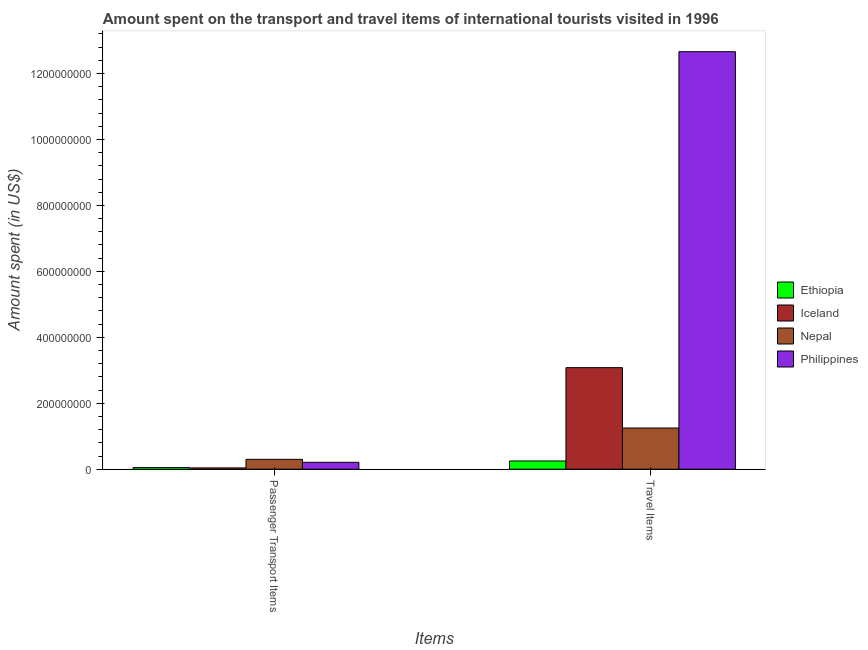How many groups of bars are there?
Ensure brevity in your answer.  2. What is the label of the 2nd group of bars from the left?
Provide a succinct answer. Travel Items. What is the amount spent in travel items in Nepal?
Provide a short and direct response. 1.25e+08. Across all countries, what is the maximum amount spent on passenger transport items?
Provide a short and direct response. 3.00e+07. Across all countries, what is the minimum amount spent on passenger transport items?
Give a very brief answer. 4.00e+06. In which country was the amount spent on passenger transport items maximum?
Offer a very short reply. Nepal. What is the total amount spent on passenger transport items in the graph?
Your answer should be compact. 6.00e+07. What is the difference between the amount spent on passenger transport items in Nepal and that in Iceland?
Provide a short and direct response. 2.60e+07. What is the difference between the amount spent on passenger transport items in Iceland and the amount spent in travel items in Ethiopia?
Give a very brief answer. -2.10e+07. What is the average amount spent in travel items per country?
Ensure brevity in your answer.  4.31e+08. What is the difference between the amount spent in travel items and amount spent on passenger transport items in Ethiopia?
Provide a succinct answer. 2.00e+07. What is the ratio of the amount spent in travel items in Philippines to that in Iceland?
Your answer should be very brief. 4.11. Is the amount spent in travel items in Nepal less than that in Iceland?
Your response must be concise. Yes. What does the 3rd bar from the left in Passenger Transport Items represents?
Your answer should be compact. Nepal. What does the 1st bar from the right in Travel Items represents?
Make the answer very short. Philippines. Are the values on the major ticks of Y-axis written in scientific E-notation?
Your answer should be very brief. No. Does the graph contain grids?
Provide a short and direct response. No. How many legend labels are there?
Make the answer very short. 4. What is the title of the graph?
Give a very brief answer. Amount spent on the transport and travel items of international tourists visited in 1996. Does "Botswana" appear as one of the legend labels in the graph?
Ensure brevity in your answer.  No. What is the label or title of the X-axis?
Your answer should be compact. Items. What is the label or title of the Y-axis?
Provide a short and direct response. Amount spent (in US$). What is the Amount spent (in US$) in Ethiopia in Passenger Transport Items?
Make the answer very short. 5.00e+06. What is the Amount spent (in US$) in Nepal in Passenger Transport Items?
Your answer should be very brief. 3.00e+07. What is the Amount spent (in US$) of Philippines in Passenger Transport Items?
Your answer should be very brief. 2.10e+07. What is the Amount spent (in US$) in Ethiopia in Travel Items?
Provide a succinct answer. 2.50e+07. What is the Amount spent (in US$) in Iceland in Travel Items?
Provide a short and direct response. 3.08e+08. What is the Amount spent (in US$) in Nepal in Travel Items?
Make the answer very short. 1.25e+08. What is the Amount spent (in US$) of Philippines in Travel Items?
Offer a very short reply. 1.27e+09. Across all Items, what is the maximum Amount spent (in US$) of Ethiopia?
Make the answer very short. 2.50e+07. Across all Items, what is the maximum Amount spent (in US$) in Iceland?
Your answer should be very brief. 3.08e+08. Across all Items, what is the maximum Amount spent (in US$) in Nepal?
Keep it short and to the point. 1.25e+08. Across all Items, what is the maximum Amount spent (in US$) of Philippines?
Give a very brief answer. 1.27e+09. Across all Items, what is the minimum Amount spent (in US$) of Ethiopia?
Offer a terse response. 5.00e+06. Across all Items, what is the minimum Amount spent (in US$) in Nepal?
Your answer should be compact. 3.00e+07. Across all Items, what is the minimum Amount spent (in US$) of Philippines?
Provide a short and direct response. 2.10e+07. What is the total Amount spent (in US$) in Ethiopia in the graph?
Provide a succinct answer. 3.00e+07. What is the total Amount spent (in US$) of Iceland in the graph?
Offer a very short reply. 3.12e+08. What is the total Amount spent (in US$) of Nepal in the graph?
Your answer should be compact. 1.55e+08. What is the total Amount spent (in US$) of Philippines in the graph?
Keep it short and to the point. 1.29e+09. What is the difference between the Amount spent (in US$) in Ethiopia in Passenger Transport Items and that in Travel Items?
Your answer should be compact. -2.00e+07. What is the difference between the Amount spent (in US$) in Iceland in Passenger Transport Items and that in Travel Items?
Provide a short and direct response. -3.04e+08. What is the difference between the Amount spent (in US$) in Nepal in Passenger Transport Items and that in Travel Items?
Your answer should be compact. -9.50e+07. What is the difference between the Amount spent (in US$) in Philippines in Passenger Transport Items and that in Travel Items?
Your answer should be compact. -1.24e+09. What is the difference between the Amount spent (in US$) of Ethiopia in Passenger Transport Items and the Amount spent (in US$) of Iceland in Travel Items?
Provide a short and direct response. -3.03e+08. What is the difference between the Amount spent (in US$) of Ethiopia in Passenger Transport Items and the Amount spent (in US$) of Nepal in Travel Items?
Give a very brief answer. -1.20e+08. What is the difference between the Amount spent (in US$) of Ethiopia in Passenger Transport Items and the Amount spent (in US$) of Philippines in Travel Items?
Your answer should be very brief. -1.26e+09. What is the difference between the Amount spent (in US$) of Iceland in Passenger Transport Items and the Amount spent (in US$) of Nepal in Travel Items?
Ensure brevity in your answer.  -1.21e+08. What is the difference between the Amount spent (in US$) in Iceland in Passenger Transport Items and the Amount spent (in US$) in Philippines in Travel Items?
Provide a short and direct response. -1.26e+09. What is the difference between the Amount spent (in US$) of Nepal in Passenger Transport Items and the Amount spent (in US$) of Philippines in Travel Items?
Offer a very short reply. -1.24e+09. What is the average Amount spent (in US$) in Ethiopia per Items?
Give a very brief answer. 1.50e+07. What is the average Amount spent (in US$) in Iceland per Items?
Offer a terse response. 1.56e+08. What is the average Amount spent (in US$) in Nepal per Items?
Offer a terse response. 7.75e+07. What is the average Amount spent (in US$) in Philippines per Items?
Ensure brevity in your answer.  6.44e+08. What is the difference between the Amount spent (in US$) of Ethiopia and Amount spent (in US$) of Iceland in Passenger Transport Items?
Your response must be concise. 1.00e+06. What is the difference between the Amount spent (in US$) in Ethiopia and Amount spent (in US$) in Nepal in Passenger Transport Items?
Your answer should be compact. -2.50e+07. What is the difference between the Amount spent (in US$) of Ethiopia and Amount spent (in US$) of Philippines in Passenger Transport Items?
Keep it short and to the point. -1.60e+07. What is the difference between the Amount spent (in US$) of Iceland and Amount spent (in US$) of Nepal in Passenger Transport Items?
Offer a terse response. -2.60e+07. What is the difference between the Amount spent (in US$) of Iceland and Amount spent (in US$) of Philippines in Passenger Transport Items?
Offer a very short reply. -1.70e+07. What is the difference between the Amount spent (in US$) in Nepal and Amount spent (in US$) in Philippines in Passenger Transport Items?
Keep it short and to the point. 9.00e+06. What is the difference between the Amount spent (in US$) in Ethiopia and Amount spent (in US$) in Iceland in Travel Items?
Ensure brevity in your answer.  -2.83e+08. What is the difference between the Amount spent (in US$) of Ethiopia and Amount spent (in US$) of Nepal in Travel Items?
Your answer should be compact. -1.00e+08. What is the difference between the Amount spent (in US$) in Ethiopia and Amount spent (in US$) in Philippines in Travel Items?
Your response must be concise. -1.24e+09. What is the difference between the Amount spent (in US$) in Iceland and Amount spent (in US$) in Nepal in Travel Items?
Ensure brevity in your answer.  1.83e+08. What is the difference between the Amount spent (in US$) in Iceland and Amount spent (in US$) in Philippines in Travel Items?
Provide a short and direct response. -9.58e+08. What is the difference between the Amount spent (in US$) in Nepal and Amount spent (in US$) in Philippines in Travel Items?
Give a very brief answer. -1.14e+09. What is the ratio of the Amount spent (in US$) of Iceland in Passenger Transport Items to that in Travel Items?
Keep it short and to the point. 0.01. What is the ratio of the Amount spent (in US$) in Nepal in Passenger Transport Items to that in Travel Items?
Provide a succinct answer. 0.24. What is the ratio of the Amount spent (in US$) in Philippines in Passenger Transport Items to that in Travel Items?
Keep it short and to the point. 0.02. What is the difference between the highest and the second highest Amount spent (in US$) of Iceland?
Give a very brief answer. 3.04e+08. What is the difference between the highest and the second highest Amount spent (in US$) in Nepal?
Your response must be concise. 9.50e+07. What is the difference between the highest and the second highest Amount spent (in US$) of Philippines?
Keep it short and to the point. 1.24e+09. What is the difference between the highest and the lowest Amount spent (in US$) in Iceland?
Make the answer very short. 3.04e+08. What is the difference between the highest and the lowest Amount spent (in US$) in Nepal?
Your response must be concise. 9.50e+07. What is the difference between the highest and the lowest Amount spent (in US$) of Philippines?
Keep it short and to the point. 1.24e+09. 